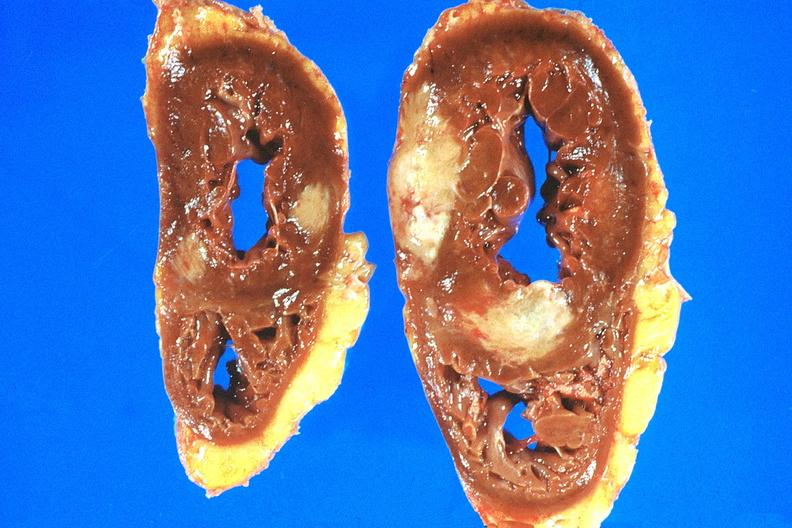what is present?
Answer the question using a single word or phrase. Cardiovascular 